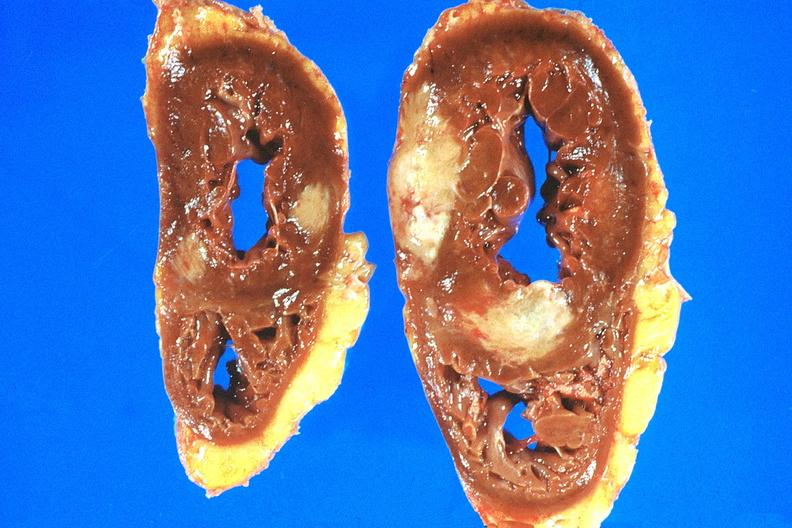what is present?
Answer the question using a single word or phrase. Cardiovascular 